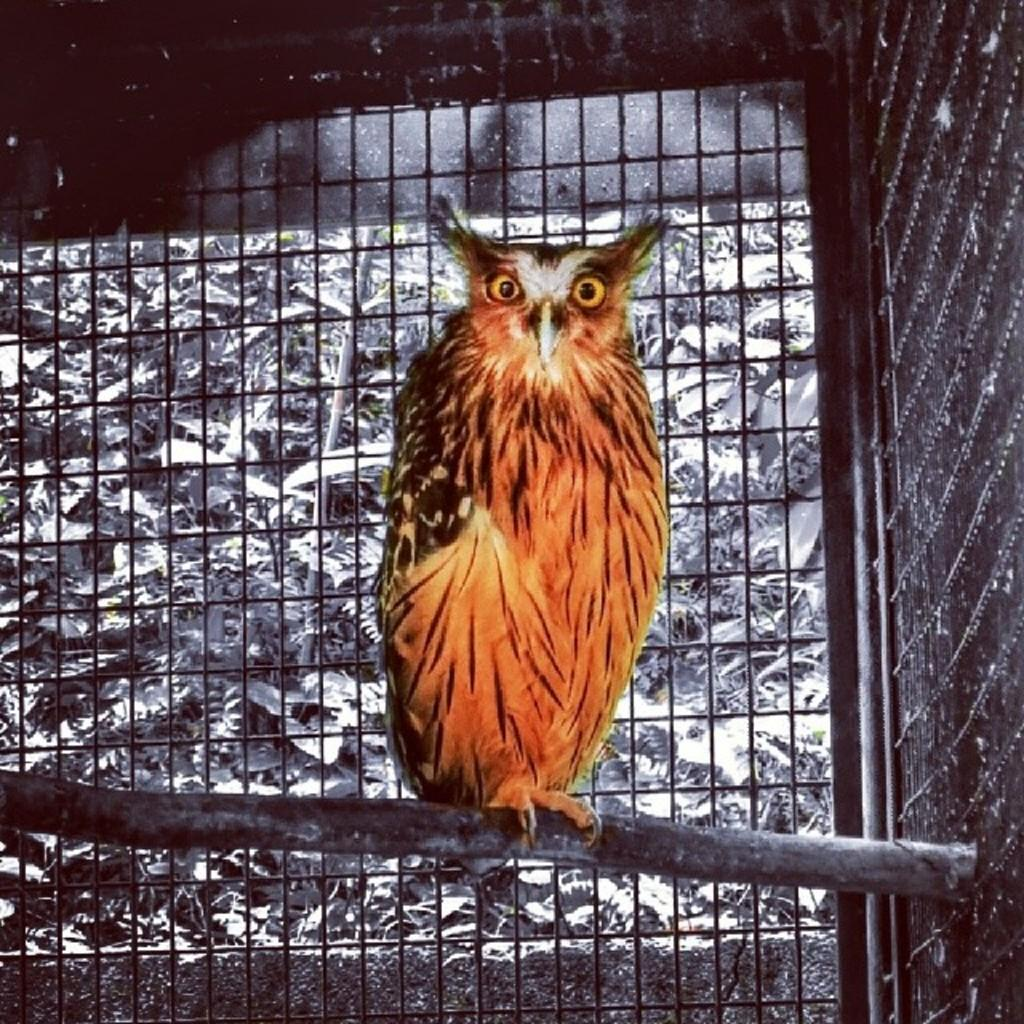What is the main subject in the center of the image? There is an owl in the center of the image. What can be seen in the background of the image? There is a mesh in the background of the image. What type of rule is being enforced by the owl in the image? There is no indication of any rule being enforced in the image; it simply features an owl in the center and a mesh in the background. 